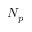Convert formula to latex. <formula><loc_0><loc_0><loc_500><loc_500>N _ { p }</formula> 